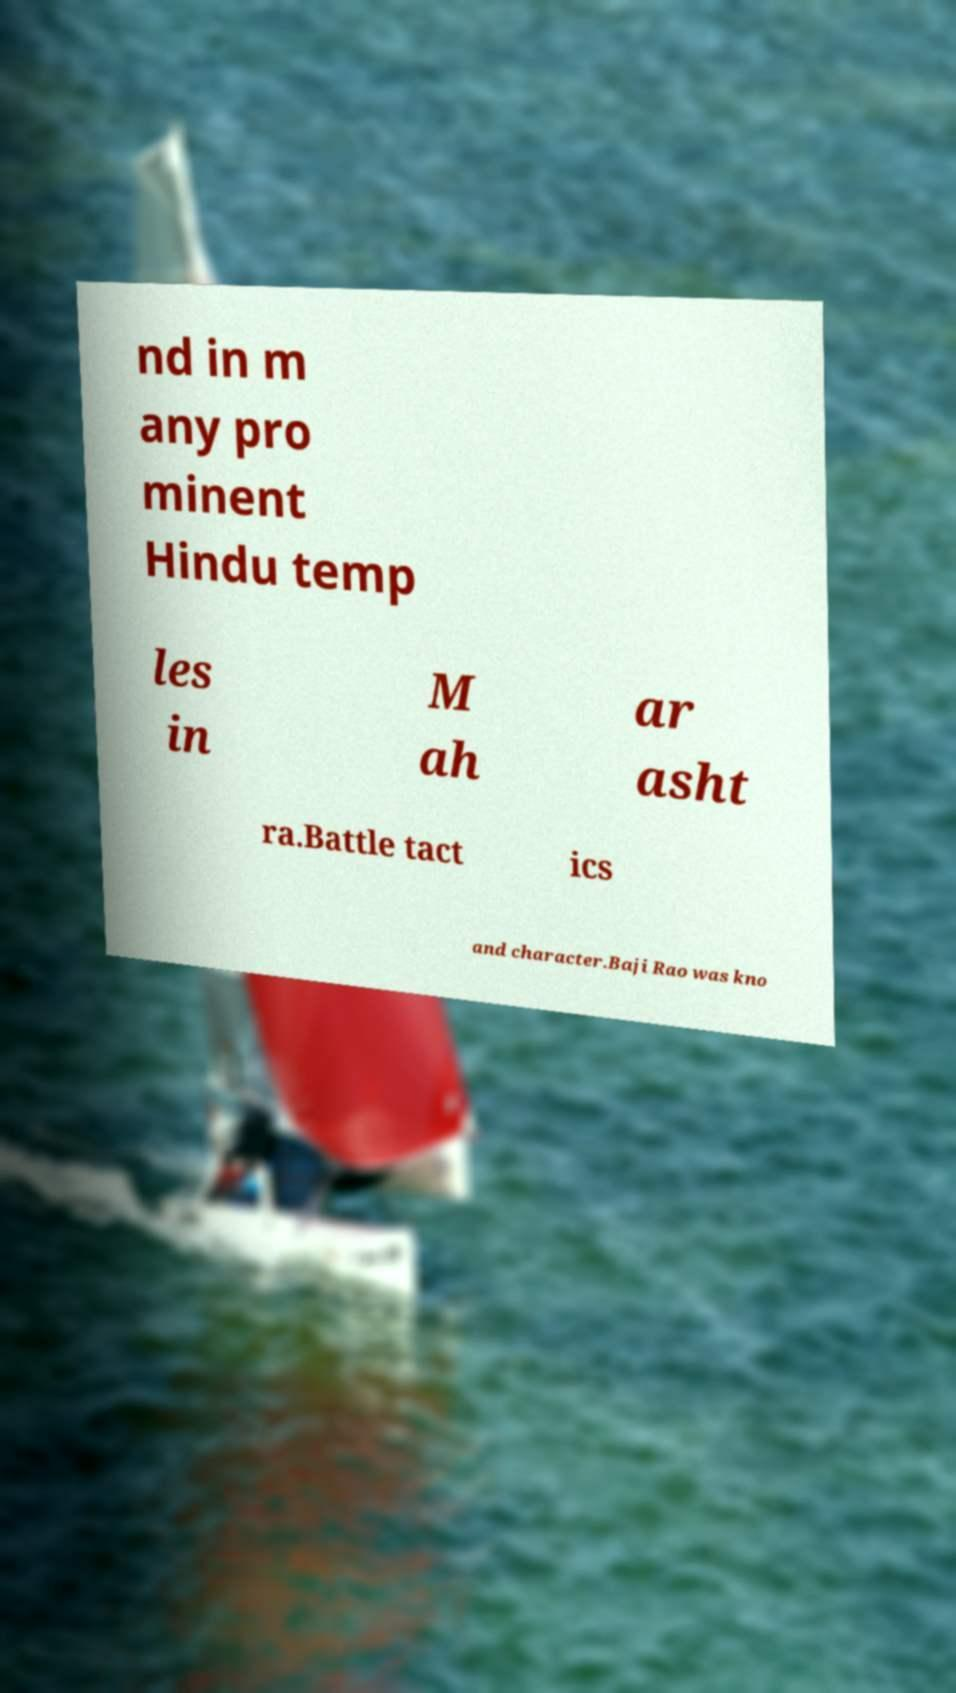Can you accurately transcribe the text from the provided image for me? nd in m any pro minent Hindu temp les in M ah ar asht ra.Battle tact ics and character.Baji Rao was kno 